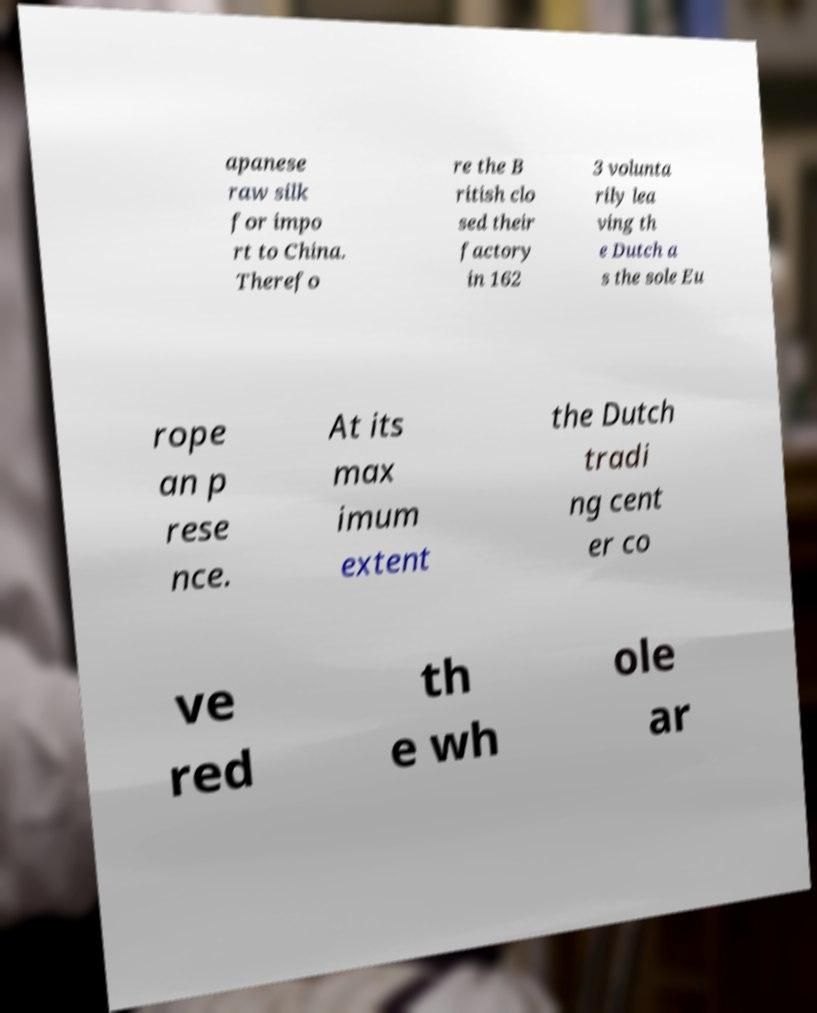Can you accurately transcribe the text from the provided image for me? apanese raw silk for impo rt to China. Therefo re the B ritish clo sed their factory in 162 3 volunta rily lea ving th e Dutch a s the sole Eu rope an p rese nce. At its max imum extent the Dutch tradi ng cent er co ve red th e wh ole ar 